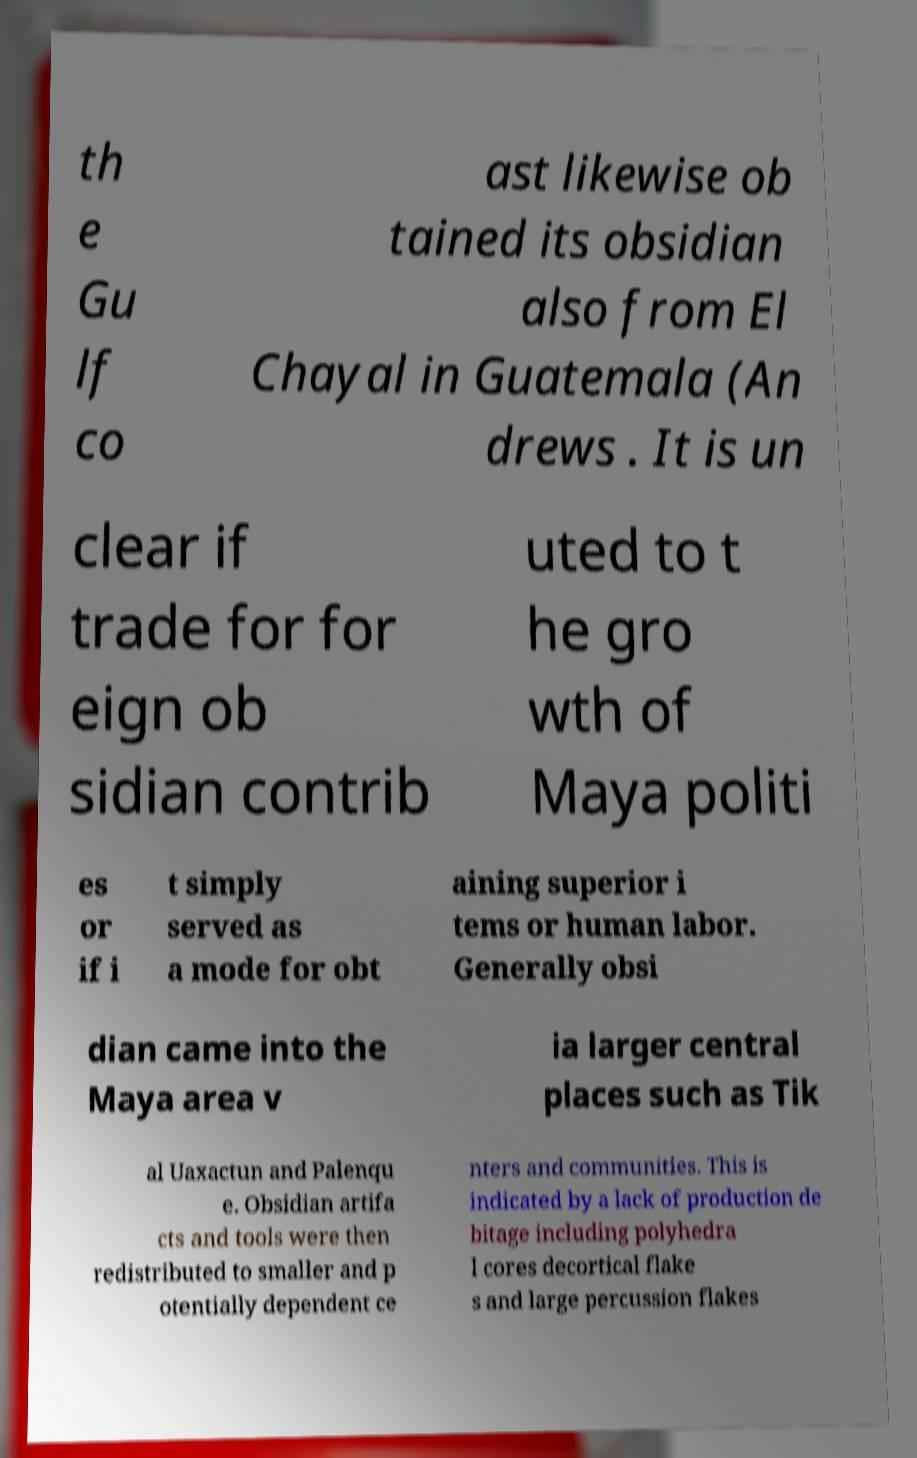For documentation purposes, I need the text within this image transcribed. Could you provide that? th e Gu lf co ast likewise ob tained its obsidian also from El Chayal in Guatemala (An drews . It is un clear if trade for for eign ob sidian contrib uted to t he gro wth of Maya politi es or if i t simply served as a mode for obt aining superior i tems or human labor. Generally obsi dian came into the Maya area v ia larger central places such as Tik al Uaxactun and Palenqu e. Obsidian artifa cts and tools were then redistributed to smaller and p otentially dependent ce nters and communities. This is indicated by a lack of production de bitage including polyhedra l cores decortical flake s and large percussion flakes 